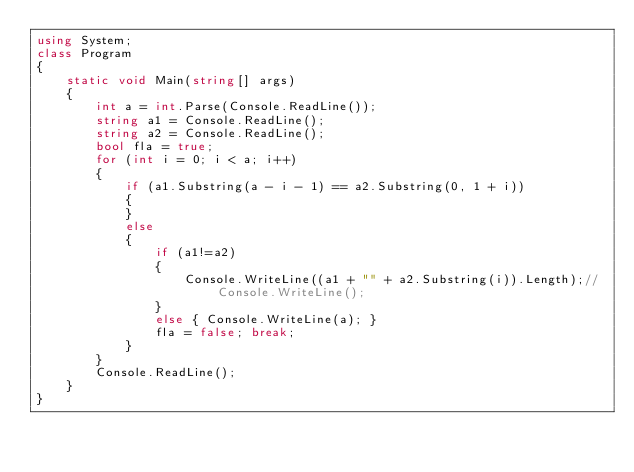Convert code to text. <code><loc_0><loc_0><loc_500><loc_500><_C#_>using System;
class Program
{
    static void Main(string[] args)
    {
        int a = int.Parse(Console.ReadLine());
        string a1 = Console.ReadLine();
        string a2 = Console.ReadLine();
        bool fla = true;
        for (int i = 0; i < a; i++)
        {
            if (a1.Substring(a - i - 1) == a2.Substring(0, 1 + i))
            {
            }
            else
            {
                if (a1!=a2)
                {
                    Console.WriteLine((a1 + "" + a2.Substring(i)).Length);// Console.WriteLine();
                }
                else { Console.WriteLine(a); }
                fla = false; break;
            }
        }
        Console.ReadLine();
    }
}
</code> 